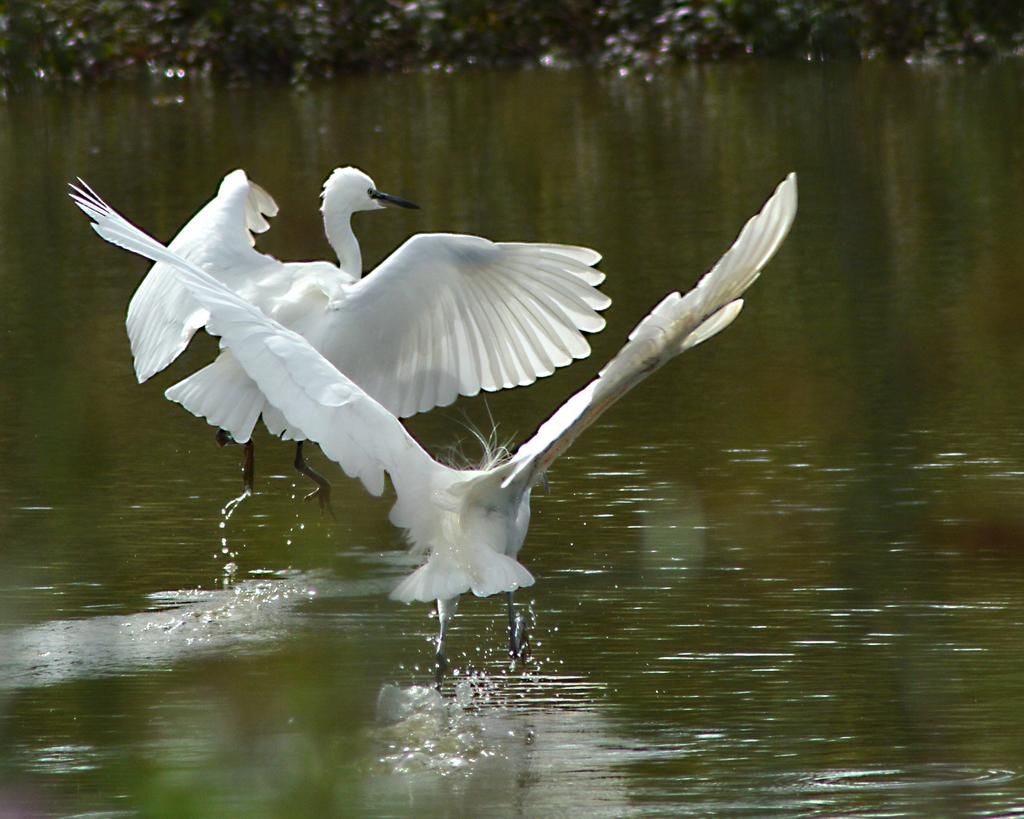What is happening in the sky in the image? There are birds flying in the air in the image. What can be seen in the background of the image? There is water visible in the background of the image. How many family members are riding bikes along the railway in the image? There are no family members, bikes, or railway present in the image; it features birds flying in the air and water in the background. 